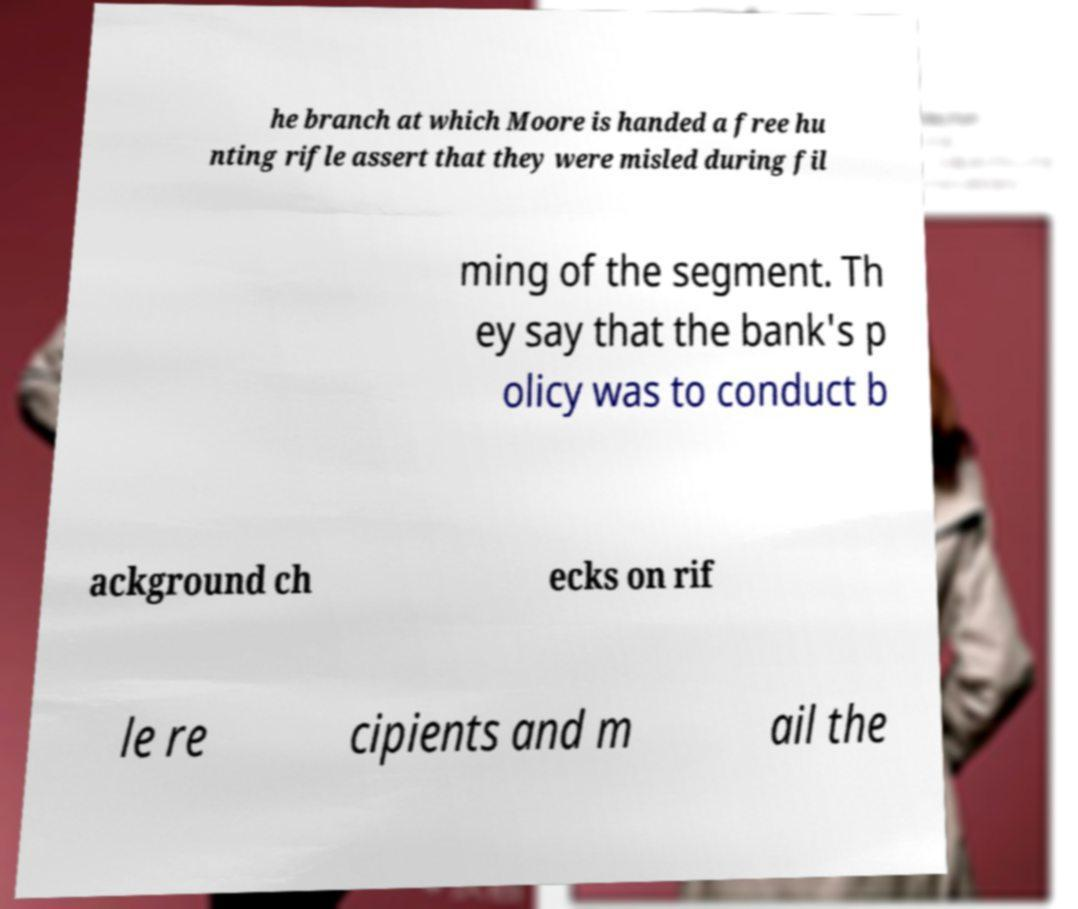There's text embedded in this image that I need extracted. Can you transcribe it verbatim? he branch at which Moore is handed a free hu nting rifle assert that they were misled during fil ming of the segment. Th ey say that the bank's p olicy was to conduct b ackground ch ecks on rif le re cipients and m ail the 